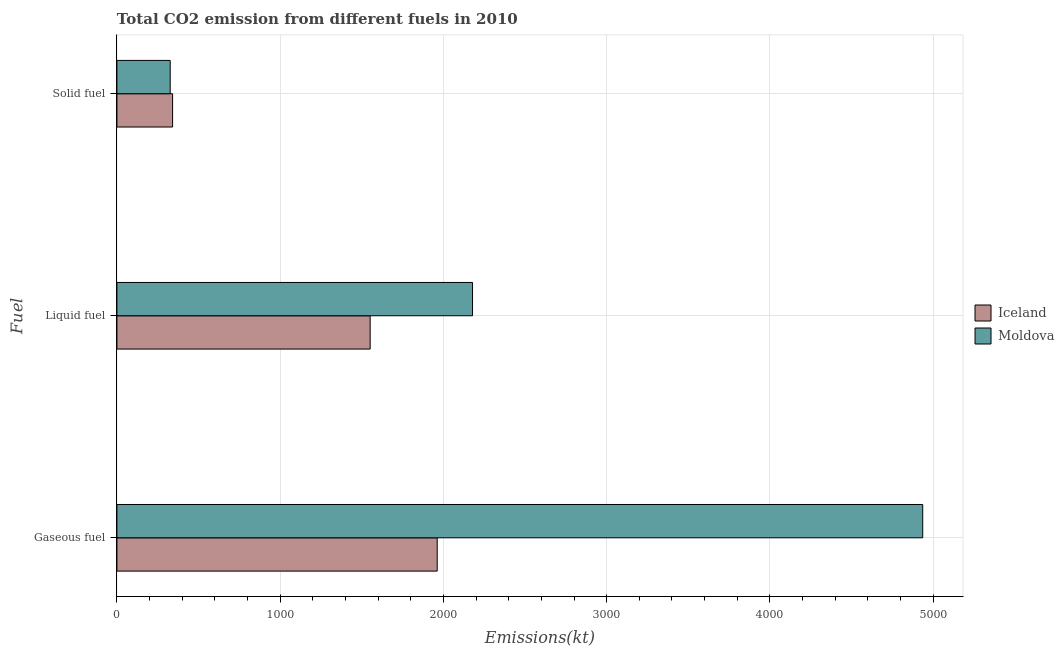How many different coloured bars are there?
Provide a short and direct response. 2. How many groups of bars are there?
Your answer should be compact. 3. Are the number of bars per tick equal to the number of legend labels?
Your answer should be compact. Yes. What is the label of the 1st group of bars from the top?
Your answer should be very brief. Solid fuel. What is the amount of co2 emissions from liquid fuel in Iceland?
Provide a short and direct response. 1551.14. Across all countries, what is the maximum amount of co2 emissions from gaseous fuel?
Make the answer very short. 4935.78. Across all countries, what is the minimum amount of co2 emissions from liquid fuel?
Your answer should be very brief. 1551.14. In which country was the amount of co2 emissions from liquid fuel maximum?
Your response must be concise. Moldova. What is the total amount of co2 emissions from solid fuel in the graph?
Your answer should be compact. 667.39. What is the difference between the amount of co2 emissions from liquid fuel in Moldova and that in Iceland?
Ensure brevity in your answer.  627.06. What is the difference between the amount of co2 emissions from liquid fuel in Moldova and the amount of co2 emissions from gaseous fuel in Iceland?
Provide a short and direct response. 216.35. What is the average amount of co2 emissions from liquid fuel per country?
Ensure brevity in your answer.  1864.67. What is the difference between the amount of co2 emissions from solid fuel and amount of co2 emissions from liquid fuel in Iceland?
Your answer should be very brief. -1210.11. In how many countries, is the amount of co2 emissions from liquid fuel greater than 200 kt?
Ensure brevity in your answer.  2. What is the ratio of the amount of co2 emissions from solid fuel in Moldova to that in Iceland?
Give a very brief answer. 0.96. Is the difference between the amount of co2 emissions from solid fuel in Iceland and Moldova greater than the difference between the amount of co2 emissions from gaseous fuel in Iceland and Moldova?
Your response must be concise. Yes. What is the difference between the highest and the second highest amount of co2 emissions from gaseous fuel?
Your answer should be compact. 2973.94. What is the difference between the highest and the lowest amount of co2 emissions from liquid fuel?
Offer a very short reply. 627.06. What does the 1st bar from the top in Solid fuel represents?
Your answer should be compact. Moldova. What does the 1st bar from the bottom in Solid fuel represents?
Offer a very short reply. Iceland. Is it the case that in every country, the sum of the amount of co2 emissions from gaseous fuel and amount of co2 emissions from liquid fuel is greater than the amount of co2 emissions from solid fuel?
Provide a short and direct response. Yes. How many bars are there?
Your answer should be very brief. 6. Are all the bars in the graph horizontal?
Provide a succinct answer. Yes. What is the difference between two consecutive major ticks on the X-axis?
Keep it short and to the point. 1000. Where does the legend appear in the graph?
Your answer should be compact. Center right. How many legend labels are there?
Provide a short and direct response. 2. How are the legend labels stacked?
Your answer should be compact. Vertical. What is the title of the graph?
Ensure brevity in your answer.  Total CO2 emission from different fuels in 2010. Does "Macao" appear as one of the legend labels in the graph?
Your answer should be very brief. No. What is the label or title of the X-axis?
Make the answer very short. Emissions(kt). What is the label or title of the Y-axis?
Ensure brevity in your answer.  Fuel. What is the Emissions(kt) of Iceland in Gaseous fuel?
Give a very brief answer. 1961.85. What is the Emissions(kt) of Moldova in Gaseous fuel?
Offer a very short reply. 4935.78. What is the Emissions(kt) in Iceland in Liquid fuel?
Provide a short and direct response. 1551.14. What is the Emissions(kt) in Moldova in Liquid fuel?
Keep it short and to the point. 2178.2. What is the Emissions(kt) of Iceland in Solid fuel?
Your response must be concise. 341.03. What is the Emissions(kt) of Moldova in Solid fuel?
Your answer should be very brief. 326.36. Across all Fuel, what is the maximum Emissions(kt) of Iceland?
Ensure brevity in your answer.  1961.85. Across all Fuel, what is the maximum Emissions(kt) in Moldova?
Your answer should be compact. 4935.78. Across all Fuel, what is the minimum Emissions(kt) of Iceland?
Provide a short and direct response. 341.03. Across all Fuel, what is the minimum Emissions(kt) of Moldova?
Your answer should be very brief. 326.36. What is the total Emissions(kt) in Iceland in the graph?
Your answer should be very brief. 3854.02. What is the total Emissions(kt) of Moldova in the graph?
Offer a very short reply. 7440.34. What is the difference between the Emissions(kt) of Iceland in Gaseous fuel and that in Liquid fuel?
Ensure brevity in your answer.  410.7. What is the difference between the Emissions(kt) of Moldova in Gaseous fuel and that in Liquid fuel?
Your response must be concise. 2757.58. What is the difference between the Emissions(kt) of Iceland in Gaseous fuel and that in Solid fuel?
Provide a succinct answer. 1620.81. What is the difference between the Emissions(kt) of Moldova in Gaseous fuel and that in Solid fuel?
Provide a succinct answer. 4609.42. What is the difference between the Emissions(kt) of Iceland in Liquid fuel and that in Solid fuel?
Offer a terse response. 1210.11. What is the difference between the Emissions(kt) of Moldova in Liquid fuel and that in Solid fuel?
Your answer should be very brief. 1851.84. What is the difference between the Emissions(kt) of Iceland in Gaseous fuel and the Emissions(kt) of Moldova in Liquid fuel?
Give a very brief answer. -216.35. What is the difference between the Emissions(kt) of Iceland in Gaseous fuel and the Emissions(kt) of Moldova in Solid fuel?
Make the answer very short. 1635.48. What is the difference between the Emissions(kt) in Iceland in Liquid fuel and the Emissions(kt) in Moldova in Solid fuel?
Provide a short and direct response. 1224.78. What is the average Emissions(kt) in Iceland per Fuel?
Make the answer very short. 1284.67. What is the average Emissions(kt) in Moldova per Fuel?
Offer a very short reply. 2480.11. What is the difference between the Emissions(kt) of Iceland and Emissions(kt) of Moldova in Gaseous fuel?
Ensure brevity in your answer.  -2973.94. What is the difference between the Emissions(kt) of Iceland and Emissions(kt) of Moldova in Liquid fuel?
Provide a short and direct response. -627.06. What is the difference between the Emissions(kt) of Iceland and Emissions(kt) of Moldova in Solid fuel?
Your answer should be compact. 14.67. What is the ratio of the Emissions(kt) of Iceland in Gaseous fuel to that in Liquid fuel?
Provide a short and direct response. 1.26. What is the ratio of the Emissions(kt) of Moldova in Gaseous fuel to that in Liquid fuel?
Offer a very short reply. 2.27. What is the ratio of the Emissions(kt) of Iceland in Gaseous fuel to that in Solid fuel?
Offer a terse response. 5.75. What is the ratio of the Emissions(kt) in Moldova in Gaseous fuel to that in Solid fuel?
Your response must be concise. 15.12. What is the ratio of the Emissions(kt) in Iceland in Liquid fuel to that in Solid fuel?
Your answer should be compact. 4.55. What is the ratio of the Emissions(kt) in Moldova in Liquid fuel to that in Solid fuel?
Provide a short and direct response. 6.67. What is the difference between the highest and the second highest Emissions(kt) of Iceland?
Provide a succinct answer. 410.7. What is the difference between the highest and the second highest Emissions(kt) in Moldova?
Give a very brief answer. 2757.58. What is the difference between the highest and the lowest Emissions(kt) of Iceland?
Make the answer very short. 1620.81. What is the difference between the highest and the lowest Emissions(kt) of Moldova?
Keep it short and to the point. 4609.42. 